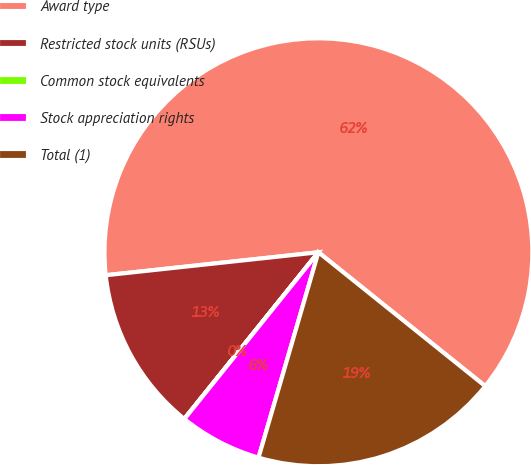<chart> <loc_0><loc_0><loc_500><loc_500><pie_chart><fcel>Award type<fcel>Restricted stock units (RSUs)<fcel>Common stock equivalents<fcel>Stock appreciation rights<fcel>Total (1)<nl><fcel>62.47%<fcel>12.5%<fcel>0.01%<fcel>6.26%<fcel>18.75%<nl></chart> 